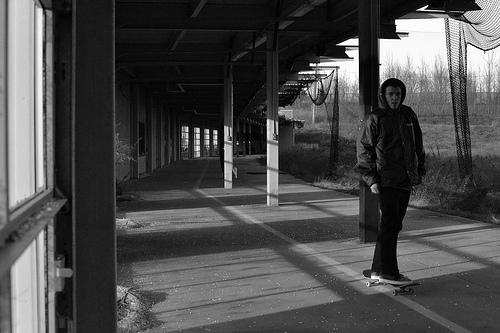Describe the attire of the person in the image. The man is wearing a black hooded jacket, a long sleeve shirt, black pants, and black tennis shoes with white soles. What is happening with the man and the skateboard in the image? The man is riding a skateboard outside on the sidewalk. What brand of shoes is the man wearing in the image? The man is wearing Vans brand shoes. Identify one object in the image used for skateboarding. A white skateboard with a black decal on its surface. What is the person in the image wearing on their feet? The man is wearing black sneakers with white soles. Select an outdoor element seen in the image. Sunlight shining on the ground. Mention a feature of the skateboarder's attire that is mentioned more than once in the image descriptions. The man has a hood on his head. Point out a detail about the surroundings of the person in the image. There are trees behind the person and weeds nearby. Choose a piece of sports equipment found in the image. A skateboard rolling on the ground. Find a structural element of the location where the person is skateboarding. A white line painted on the concrete. 